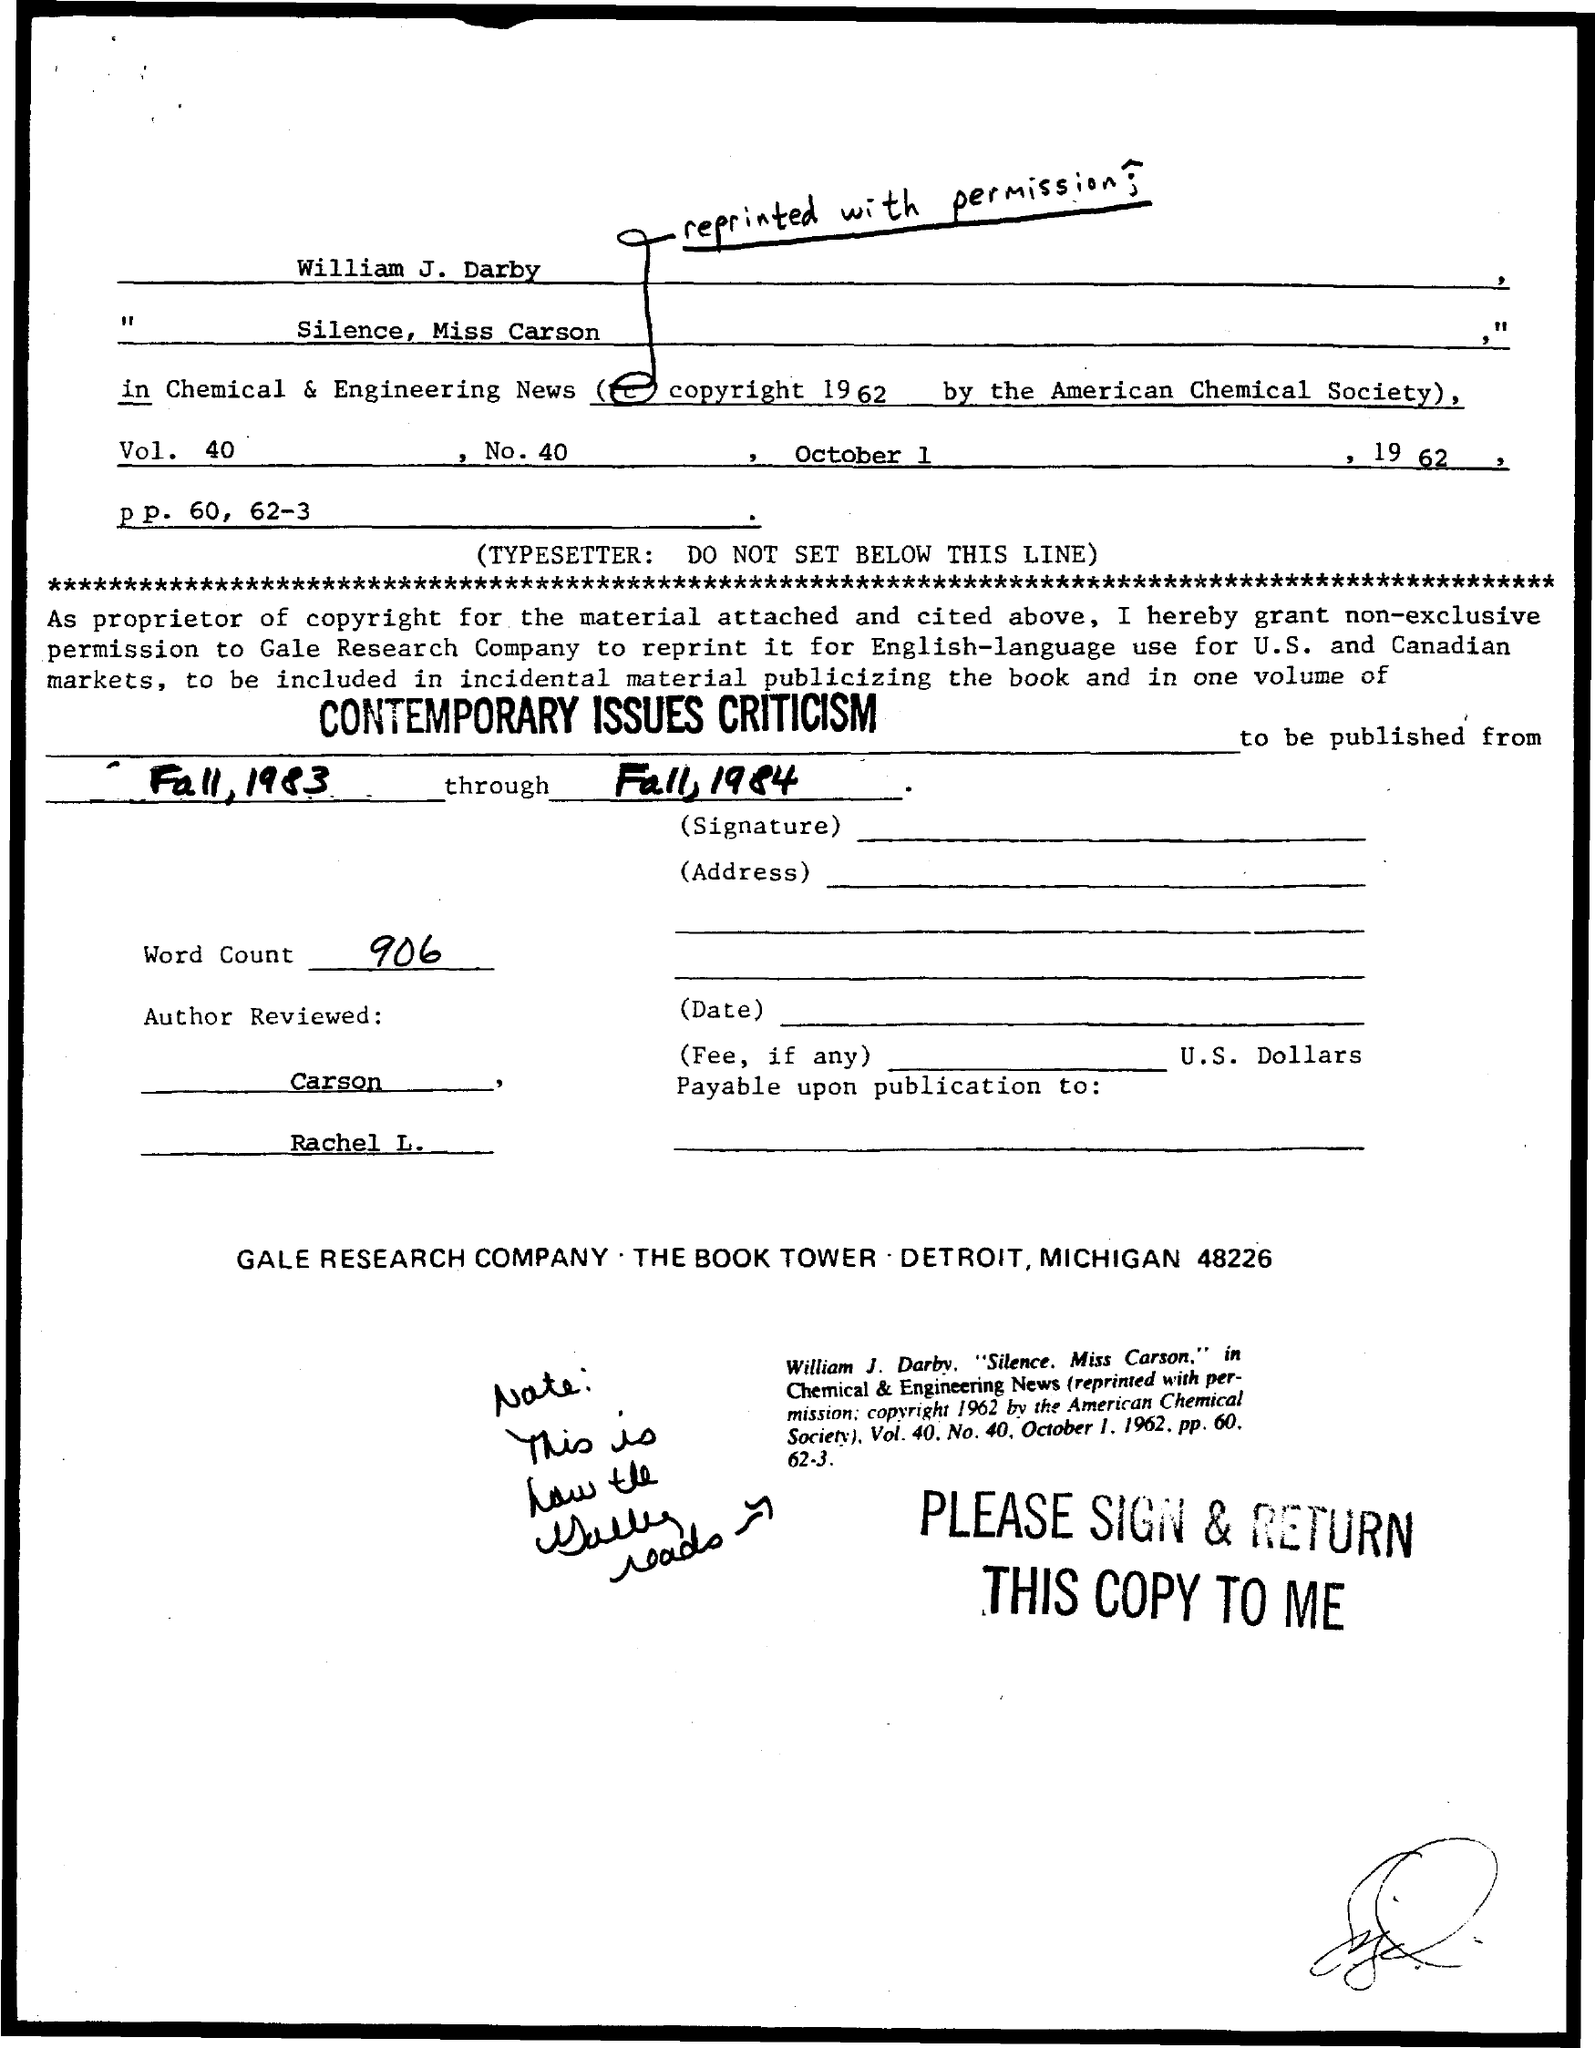What is the date mentioned ?
Provide a short and direct response. October 1 , 1962. What is the word count mentioned ?
Make the answer very short. 906. What is the vol. no. mentioned ?
Provide a succinct answer. 40. What is the no. mentioned ?
Provide a succinct answer. 40. 